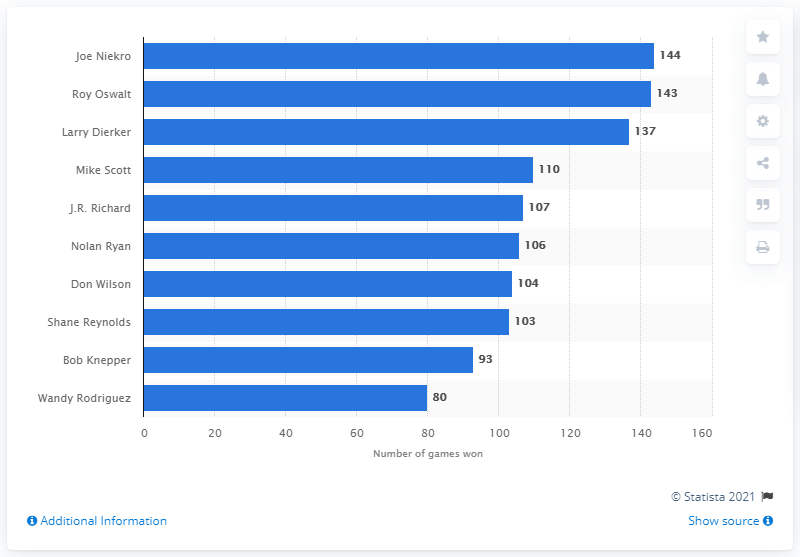Mention a couple of crucial points in this snapshot. Joe Niekro won the most games for the Houston Astros with a total of 144 victories. The Houston Astros franchise has a rich history of exceptional play, and one player who stands out as having achieved remarkable success is Joe Niekro. Throughout his time with the team, Joe Niekro consistently demonstrated his skill and determination on the field, ultimately earning the title of having won the most games in Houston Astros franchise history. 